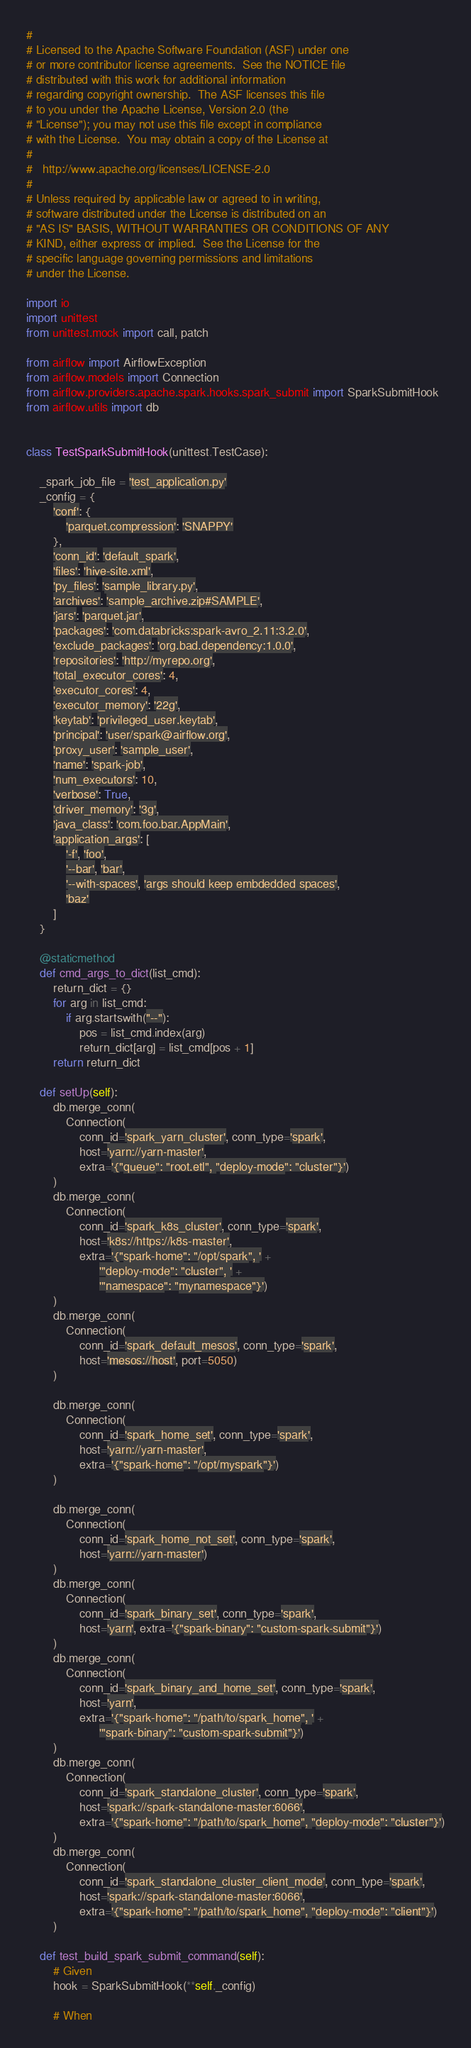<code> <loc_0><loc_0><loc_500><loc_500><_Python_>#
# Licensed to the Apache Software Foundation (ASF) under one
# or more contributor license agreements.  See the NOTICE file
# distributed with this work for additional information
# regarding copyright ownership.  The ASF licenses this file
# to you under the Apache License, Version 2.0 (the
# "License"); you may not use this file except in compliance
# with the License.  You may obtain a copy of the License at
#
#   http://www.apache.org/licenses/LICENSE-2.0
#
# Unless required by applicable law or agreed to in writing,
# software distributed under the License is distributed on an
# "AS IS" BASIS, WITHOUT WARRANTIES OR CONDITIONS OF ANY
# KIND, either express or implied.  See the License for the
# specific language governing permissions and limitations
# under the License.

import io
import unittest
from unittest.mock import call, patch

from airflow import AirflowException
from airflow.models import Connection
from airflow.providers.apache.spark.hooks.spark_submit import SparkSubmitHook
from airflow.utils import db


class TestSparkSubmitHook(unittest.TestCase):

    _spark_job_file = 'test_application.py'
    _config = {
        'conf': {
            'parquet.compression': 'SNAPPY'
        },
        'conn_id': 'default_spark',
        'files': 'hive-site.xml',
        'py_files': 'sample_library.py',
        'archives': 'sample_archive.zip#SAMPLE',
        'jars': 'parquet.jar',
        'packages': 'com.databricks:spark-avro_2.11:3.2.0',
        'exclude_packages': 'org.bad.dependency:1.0.0',
        'repositories': 'http://myrepo.org',
        'total_executor_cores': 4,
        'executor_cores': 4,
        'executor_memory': '22g',
        'keytab': 'privileged_user.keytab',
        'principal': 'user/spark@airflow.org',
        'proxy_user': 'sample_user',
        'name': 'spark-job',
        'num_executors': 10,
        'verbose': True,
        'driver_memory': '3g',
        'java_class': 'com.foo.bar.AppMain',
        'application_args': [
            '-f', 'foo',
            '--bar', 'bar',
            '--with-spaces', 'args should keep embdedded spaces',
            'baz'
        ]
    }

    @staticmethod
    def cmd_args_to_dict(list_cmd):
        return_dict = {}
        for arg in list_cmd:
            if arg.startswith("--"):
                pos = list_cmd.index(arg)
                return_dict[arg] = list_cmd[pos + 1]
        return return_dict

    def setUp(self):
        db.merge_conn(
            Connection(
                conn_id='spark_yarn_cluster', conn_type='spark',
                host='yarn://yarn-master',
                extra='{"queue": "root.etl", "deploy-mode": "cluster"}')
        )
        db.merge_conn(
            Connection(
                conn_id='spark_k8s_cluster', conn_type='spark',
                host='k8s://https://k8s-master',
                extra='{"spark-home": "/opt/spark", ' +
                      '"deploy-mode": "cluster", ' +
                      '"namespace": "mynamespace"}')
        )
        db.merge_conn(
            Connection(
                conn_id='spark_default_mesos', conn_type='spark',
                host='mesos://host', port=5050)
        )

        db.merge_conn(
            Connection(
                conn_id='spark_home_set', conn_type='spark',
                host='yarn://yarn-master',
                extra='{"spark-home": "/opt/myspark"}')
        )

        db.merge_conn(
            Connection(
                conn_id='spark_home_not_set', conn_type='spark',
                host='yarn://yarn-master')
        )
        db.merge_conn(
            Connection(
                conn_id='spark_binary_set', conn_type='spark',
                host='yarn', extra='{"spark-binary": "custom-spark-submit"}')
        )
        db.merge_conn(
            Connection(
                conn_id='spark_binary_and_home_set', conn_type='spark',
                host='yarn',
                extra='{"spark-home": "/path/to/spark_home", ' +
                      '"spark-binary": "custom-spark-submit"}')
        )
        db.merge_conn(
            Connection(
                conn_id='spark_standalone_cluster', conn_type='spark',
                host='spark://spark-standalone-master:6066',
                extra='{"spark-home": "/path/to/spark_home", "deploy-mode": "cluster"}')
        )
        db.merge_conn(
            Connection(
                conn_id='spark_standalone_cluster_client_mode', conn_type='spark',
                host='spark://spark-standalone-master:6066',
                extra='{"spark-home": "/path/to/spark_home", "deploy-mode": "client"}')
        )

    def test_build_spark_submit_command(self):
        # Given
        hook = SparkSubmitHook(**self._config)

        # When</code> 